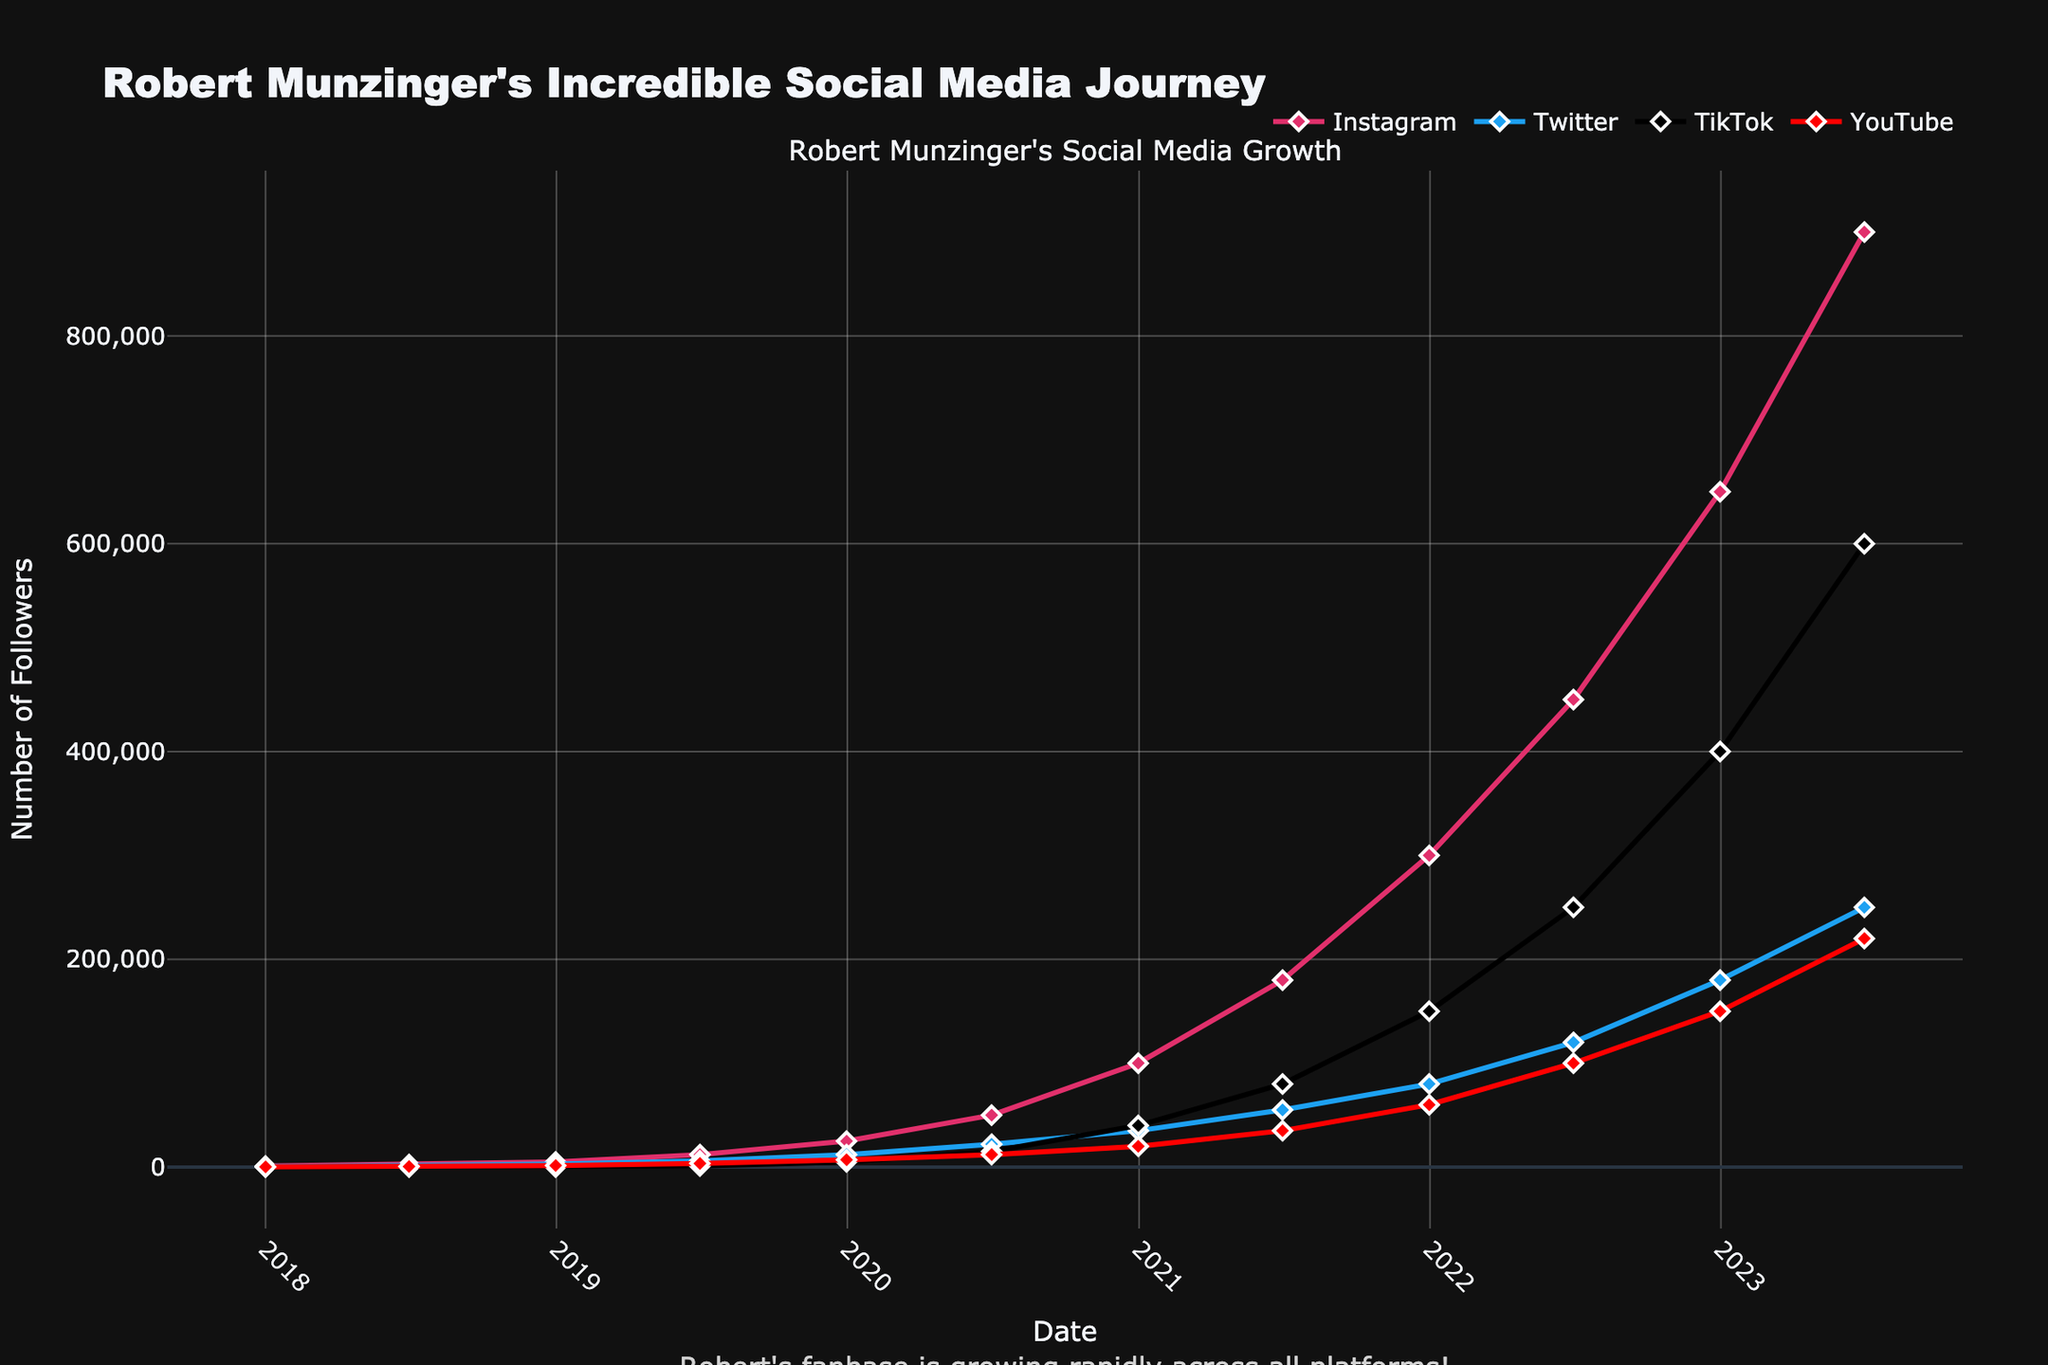What is the total increase in Instagram followers from 2018 to 2023? First, note the Instagram follower count in 2018, which is 1000, and in 2023, which is 900000. Calculate the difference: 900000 - 1000 = 899000.
Answer: 899000 Which platform had the highest number of followers at the end of 2023? Examine the follower counts for Instagram (900000), Twitter (250000), TikTok (600000), and YouTube (220000) in 2023. The highest value is for Instagram.
Answer: Instagram Between which two dates did TikTok see its most significant growth in followers? Compare the differences between the TikTok follower counts at each interval. The largest change occurred between the end of 2022 (400000) and mid-2023 (600000), a growth of 200000 followers.
Answer: End of 2022 and mid-2023 Which social media platform had the smallest follower base at the end of 2018? Look at the follower counts for each platform at the end of 2018: Instagram (5000), Twitter (2800), TikTok (0), and YouTube (1500). TikTok had 0 followers, the smallest count.
Answer: TikTok How did the number of YouTube followers change from mid-2021 to mid-2022? Note the YouTube follower count from mid-2021 (35000) to mid-2022 (100000). Calculate the difference: 100000 - 35000 = 65000.
Answer: Increased by 65000 Compare the growth of Twitter and YouTube followers from mid-2020 to the end of 2021. Which platform grew more, and by how much? Calculate the differences for Twitter: from 22000 to 80000 (80000-22000=58000) and for YouTube: from 12000 to 60000 (60000-12000=48000). Twitter grew more by 58000 - 48000 = 10000.
Answer: Twitter by 10000 What is the average number of TikTok followers at the end of each year from 2019 to 2023? Add the end-of-year follower counts for TikTok (2019: 5000, 2020: 40000, 2021: 150000, 2022: 400000, 2023: 600000). Calculate the average: (5000 + 40000 + 150000 + 400000 + 600000) / 5 = 238000.
Answer: 238000 Which platform experienced the first major spike in the number of followers? By observing the sharp increases, Instagram saw a sharp increase first between the end of 2018 (5000) and mid-2019 (12000).
Answer: Instagram 